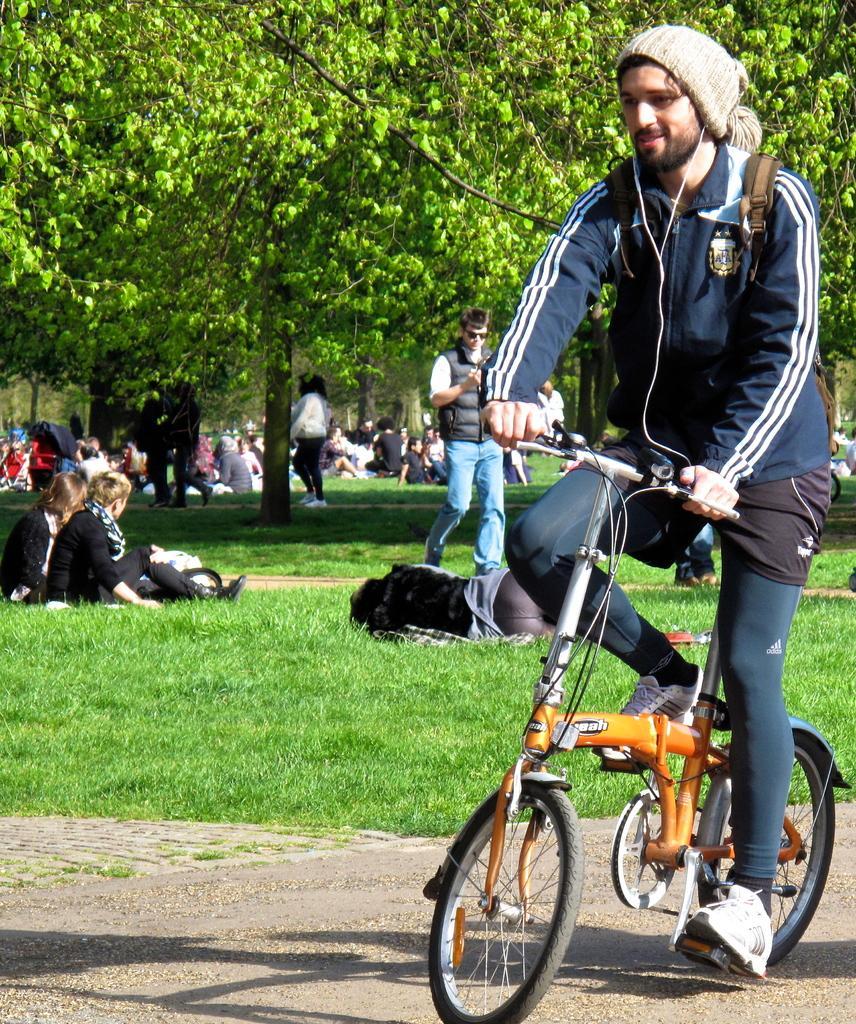Could you give a brief overview of what you see in this image? There are so many people sitting and sleeping under trees on the grass and few people walking behind that there is a man riding bicycle on the road. 